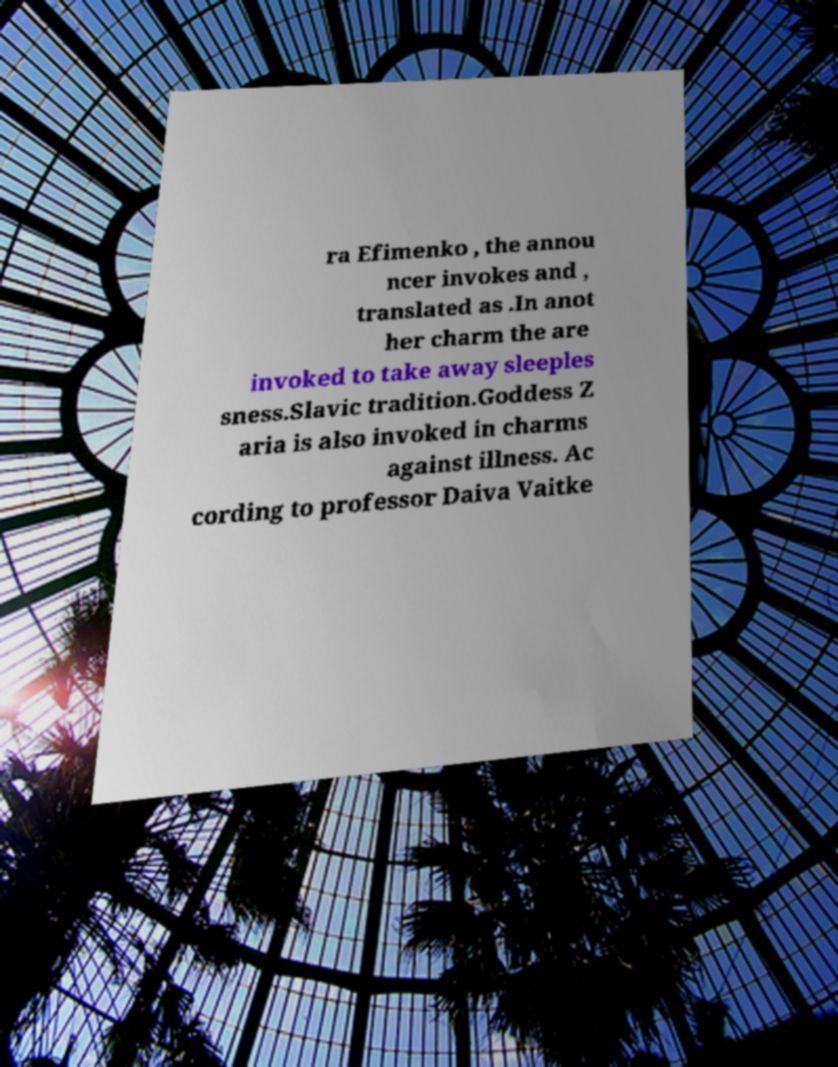Please read and relay the text visible in this image. What does it say? ra Efimenko , the annou ncer invokes and , translated as .In anot her charm the are invoked to take away sleeples sness.Slavic tradition.Goddess Z aria is also invoked in charms against illness. Ac cording to professor Daiva Vaitke 